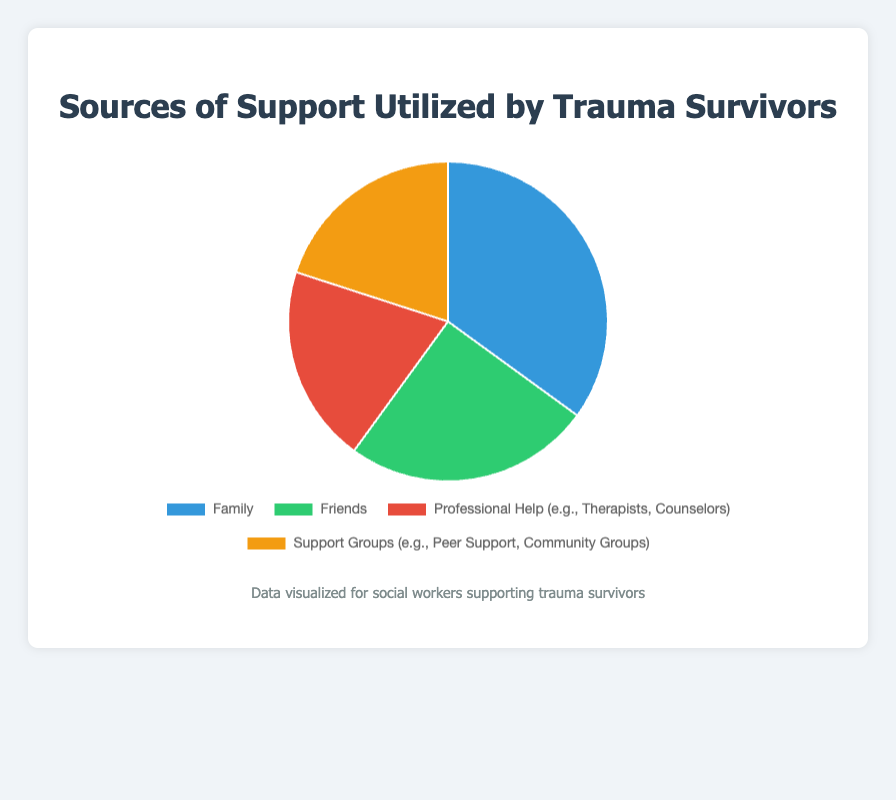What's the most utilized source of support for trauma survivors? By looking at the pie chart, identify the segment with the largest percentage. This segment represents the most utilized source of support. Family has the largest percentage at 35%.
Answer: Family How much more do trauma survivors rely on Family support compared to Friends? Subtract the percentage of Friends from the percentage of Family to find the difference. 35% (Family) - 25% (Friends) = 10%.
Answer: 10% Which sources of support are utilized equally by trauma survivors? Identify segments in the pie chart with the same percentage. Both Professional Help and Support Groups have equal shares at 20%.
Answer: Professional Help and Support Groups What percentage of trauma survivors rely on non-family support sources combined (Friends, Professional Help, Support Groups)? Add the percentages of Friends, Professional Help, and Support Groups. 25% (Friends) + 20% (Professional Help) + 20% (Support Groups) = 65%.
Answer: 65% Is the combined support from Professional Help and Support Groups greater than that from Family alone? Add the percentages of Professional Help and Support Groups, then compare to Family’s percentage. 20% (Professional Help) + 20% (Support Groups) = 40%, which is greater than 35% (Family).
Answer: Yes Which two sources of support together make up nearly half of the total support utilized by trauma survivors? Look for two segments whose combined percentage approximates 50%. Family (35%) and Friends (25%) together make 60%, while Professional Help (20%) and Support Groups (20%) together make 40%. After evaluation, Family (35%) + Professional Help (20%) is the closest to 50%.
Answer: Family and Professional Help What is the combined percentage of the least utilized support sources? Identify which source segments tie for the least percentage and then sum their values. Professional Help and Support Groups are tied at 20%, summing to 40%.
Answer: 40% If a trauma survivor utilizes Family and Friends support, how much percentage of the total do they still need to reach full support utilization (100%)? Add the percentages of Family and Friends, then subtract from 100%. 35% (Family) + 25% (Friends) = 60%; therefore, 100% - 60% = 40%.
Answer: 40% 